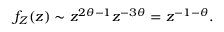<formula> <loc_0><loc_0><loc_500><loc_500>f _ { Z } ( z ) \sim z ^ { 2 \theta - 1 } z ^ { - 3 \theta } = z ^ { - 1 - \theta } .</formula> 